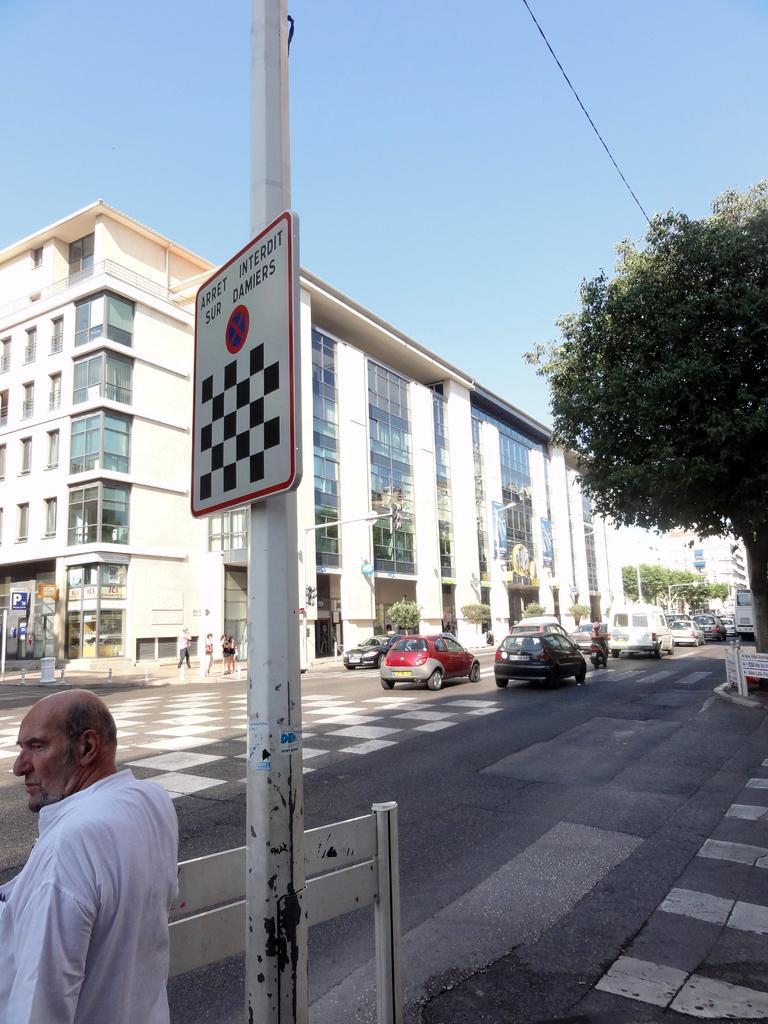Describe this image in one or two sentences. In the image there are few vehicles moving on the road and beside the vehicles there is a large tree and in the front there is a person standing in front of a pole, on the other side of the road there is a tall building and there is a parking board in front of the building. 